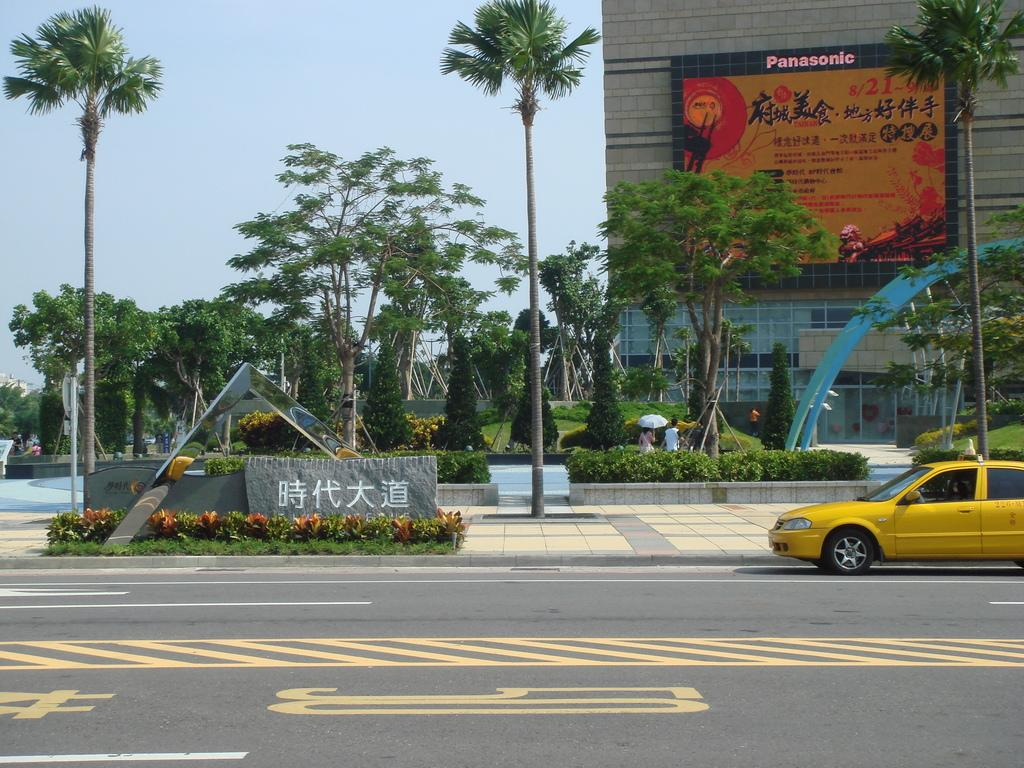<image>
Give a short and clear explanation of the subsequent image. A yellow taxi is parked in front of a building that has a Panasonic sign on it with Asian writing. 